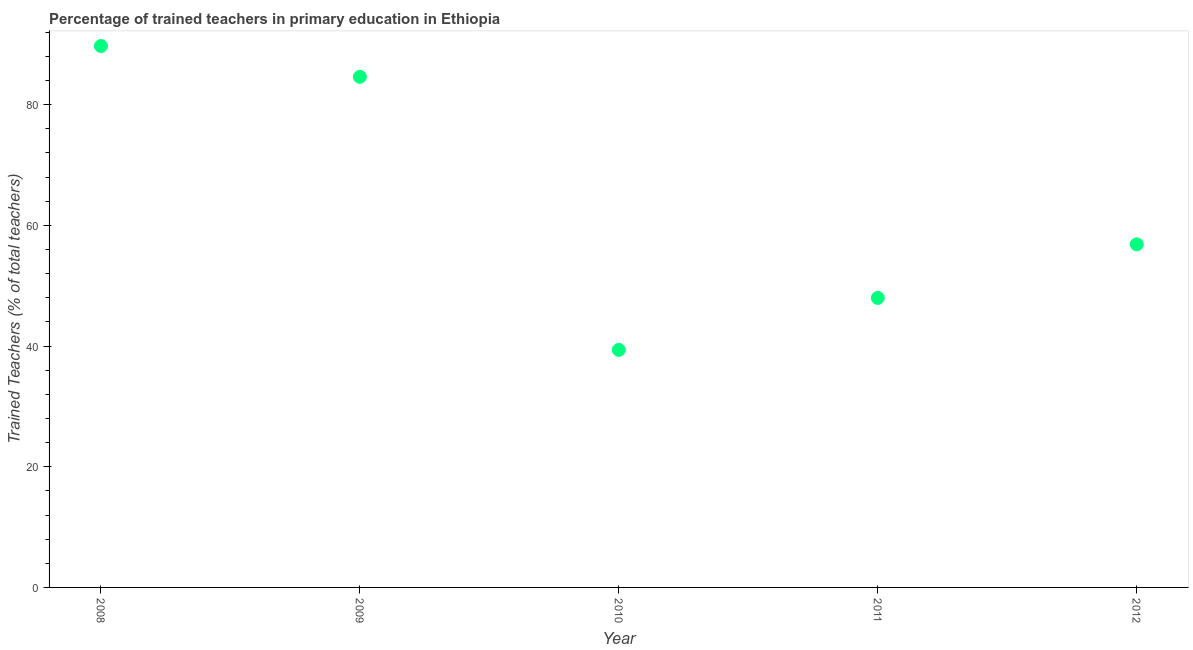What is the percentage of trained teachers in 2009?
Your response must be concise. 84.61. Across all years, what is the maximum percentage of trained teachers?
Provide a succinct answer. 89.72. Across all years, what is the minimum percentage of trained teachers?
Your response must be concise. 39.36. In which year was the percentage of trained teachers maximum?
Your answer should be compact. 2008. In which year was the percentage of trained teachers minimum?
Provide a succinct answer. 2010. What is the sum of the percentage of trained teachers?
Offer a terse response. 318.51. What is the difference between the percentage of trained teachers in 2009 and 2012?
Give a very brief answer. 27.76. What is the average percentage of trained teachers per year?
Ensure brevity in your answer.  63.7. What is the median percentage of trained teachers?
Offer a terse response. 56.85. In how many years, is the percentage of trained teachers greater than 28 %?
Keep it short and to the point. 5. What is the ratio of the percentage of trained teachers in 2008 to that in 2010?
Offer a terse response. 2.28. Is the percentage of trained teachers in 2010 less than that in 2012?
Offer a terse response. Yes. Is the difference between the percentage of trained teachers in 2009 and 2010 greater than the difference between any two years?
Give a very brief answer. No. What is the difference between the highest and the second highest percentage of trained teachers?
Your response must be concise. 5.11. What is the difference between the highest and the lowest percentage of trained teachers?
Offer a very short reply. 50.35. In how many years, is the percentage of trained teachers greater than the average percentage of trained teachers taken over all years?
Offer a terse response. 2. Does the percentage of trained teachers monotonically increase over the years?
Ensure brevity in your answer.  No. How many years are there in the graph?
Your response must be concise. 5. Does the graph contain any zero values?
Provide a succinct answer. No. Does the graph contain grids?
Provide a succinct answer. No. What is the title of the graph?
Give a very brief answer. Percentage of trained teachers in primary education in Ethiopia. What is the label or title of the X-axis?
Provide a succinct answer. Year. What is the label or title of the Y-axis?
Ensure brevity in your answer.  Trained Teachers (% of total teachers). What is the Trained Teachers (% of total teachers) in 2008?
Keep it short and to the point. 89.72. What is the Trained Teachers (% of total teachers) in 2009?
Your answer should be compact. 84.61. What is the Trained Teachers (% of total teachers) in 2010?
Your response must be concise. 39.36. What is the Trained Teachers (% of total teachers) in 2011?
Your answer should be very brief. 47.97. What is the Trained Teachers (% of total teachers) in 2012?
Provide a short and direct response. 56.85. What is the difference between the Trained Teachers (% of total teachers) in 2008 and 2009?
Keep it short and to the point. 5.11. What is the difference between the Trained Teachers (% of total teachers) in 2008 and 2010?
Your response must be concise. 50.35. What is the difference between the Trained Teachers (% of total teachers) in 2008 and 2011?
Provide a short and direct response. 41.74. What is the difference between the Trained Teachers (% of total teachers) in 2008 and 2012?
Offer a very short reply. 32.87. What is the difference between the Trained Teachers (% of total teachers) in 2009 and 2010?
Provide a succinct answer. 45.25. What is the difference between the Trained Teachers (% of total teachers) in 2009 and 2011?
Keep it short and to the point. 36.64. What is the difference between the Trained Teachers (% of total teachers) in 2009 and 2012?
Keep it short and to the point. 27.76. What is the difference between the Trained Teachers (% of total teachers) in 2010 and 2011?
Your answer should be compact. -8.61. What is the difference between the Trained Teachers (% of total teachers) in 2010 and 2012?
Ensure brevity in your answer.  -17.49. What is the difference between the Trained Teachers (% of total teachers) in 2011 and 2012?
Give a very brief answer. -8.87. What is the ratio of the Trained Teachers (% of total teachers) in 2008 to that in 2009?
Offer a terse response. 1.06. What is the ratio of the Trained Teachers (% of total teachers) in 2008 to that in 2010?
Offer a very short reply. 2.28. What is the ratio of the Trained Teachers (% of total teachers) in 2008 to that in 2011?
Your response must be concise. 1.87. What is the ratio of the Trained Teachers (% of total teachers) in 2008 to that in 2012?
Make the answer very short. 1.58. What is the ratio of the Trained Teachers (% of total teachers) in 2009 to that in 2010?
Your answer should be very brief. 2.15. What is the ratio of the Trained Teachers (% of total teachers) in 2009 to that in 2011?
Provide a succinct answer. 1.76. What is the ratio of the Trained Teachers (% of total teachers) in 2009 to that in 2012?
Offer a very short reply. 1.49. What is the ratio of the Trained Teachers (% of total teachers) in 2010 to that in 2011?
Offer a terse response. 0.82. What is the ratio of the Trained Teachers (% of total teachers) in 2010 to that in 2012?
Provide a succinct answer. 0.69. What is the ratio of the Trained Teachers (% of total teachers) in 2011 to that in 2012?
Keep it short and to the point. 0.84. 